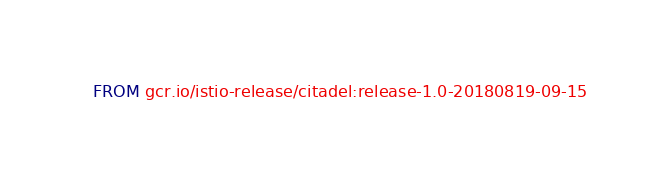<code> <loc_0><loc_0><loc_500><loc_500><_Dockerfile_>FROM gcr.io/istio-release/citadel:release-1.0-20180819-09-15
</code> 